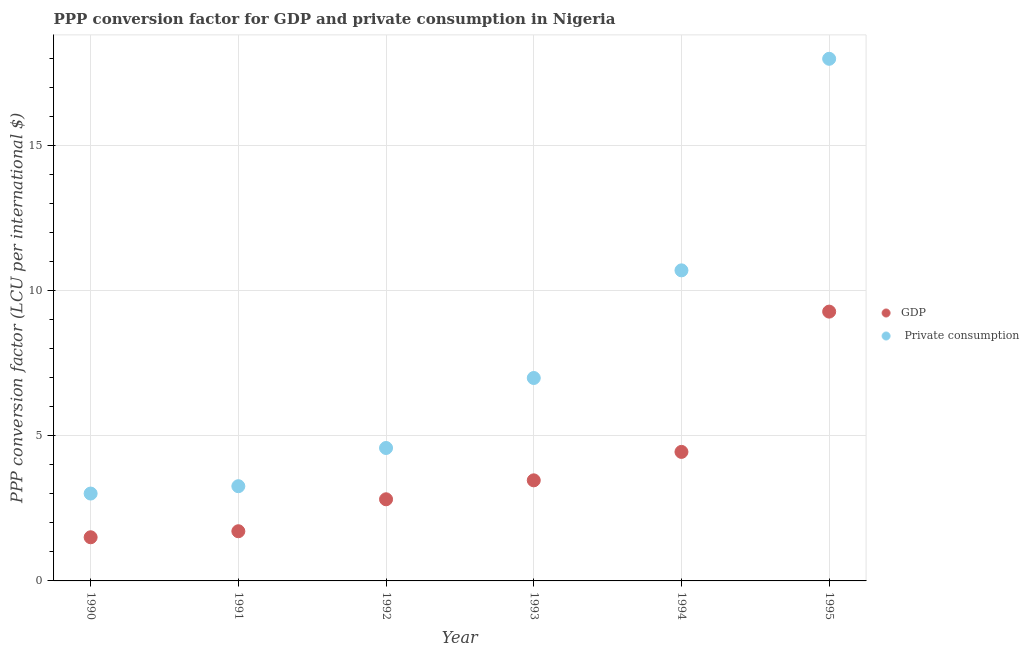How many different coloured dotlines are there?
Offer a very short reply. 2. Is the number of dotlines equal to the number of legend labels?
Make the answer very short. Yes. What is the ppp conversion factor for gdp in 1995?
Your answer should be very brief. 9.27. Across all years, what is the maximum ppp conversion factor for private consumption?
Your response must be concise. 17.98. Across all years, what is the minimum ppp conversion factor for private consumption?
Offer a very short reply. 3.01. In which year was the ppp conversion factor for private consumption maximum?
Your answer should be compact. 1995. What is the total ppp conversion factor for private consumption in the graph?
Ensure brevity in your answer.  46.52. What is the difference between the ppp conversion factor for gdp in 1990 and that in 1994?
Your answer should be compact. -2.94. What is the difference between the ppp conversion factor for gdp in 1990 and the ppp conversion factor for private consumption in 1991?
Your answer should be compact. -1.76. What is the average ppp conversion factor for private consumption per year?
Give a very brief answer. 7.75. In the year 1994, what is the difference between the ppp conversion factor for gdp and ppp conversion factor for private consumption?
Your answer should be very brief. -6.25. What is the ratio of the ppp conversion factor for gdp in 1994 to that in 1995?
Offer a terse response. 0.48. Is the ppp conversion factor for private consumption in 1991 less than that in 1992?
Give a very brief answer. Yes. What is the difference between the highest and the second highest ppp conversion factor for gdp?
Give a very brief answer. 4.83. What is the difference between the highest and the lowest ppp conversion factor for private consumption?
Your response must be concise. 14.97. In how many years, is the ppp conversion factor for private consumption greater than the average ppp conversion factor for private consumption taken over all years?
Make the answer very short. 2. Is the ppp conversion factor for private consumption strictly greater than the ppp conversion factor for gdp over the years?
Provide a short and direct response. Yes. Is the ppp conversion factor for private consumption strictly less than the ppp conversion factor for gdp over the years?
Provide a succinct answer. No. Does the graph contain any zero values?
Provide a short and direct response. No. Does the graph contain grids?
Provide a short and direct response. Yes. Where does the legend appear in the graph?
Your response must be concise. Center right. How many legend labels are there?
Your answer should be very brief. 2. How are the legend labels stacked?
Your answer should be compact. Vertical. What is the title of the graph?
Keep it short and to the point. PPP conversion factor for GDP and private consumption in Nigeria. What is the label or title of the Y-axis?
Make the answer very short. PPP conversion factor (LCU per international $). What is the PPP conversion factor (LCU per international $) of GDP in 1990?
Your answer should be compact. 1.5. What is the PPP conversion factor (LCU per international $) in  Private consumption in 1990?
Offer a very short reply. 3.01. What is the PPP conversion factor (LCU per international $) of GDP in 1991?
Give a very brief answer. 1.71. What is the PPP conversion factor (LCU per international $) of  Private consumption in 1991?
Your answer should be compact. 3.26. What is the PPP conversion factor (LCU per international $) in GDP in 1992?
Your answer should be very brief. 2.81. What is the PPP conversion factor (LCU per international $) of  Private consumption in 1992?
Offer a terse response. 4.58. What is the PPP conversion factor (LCU per international $) in GDP in 1993?
Your response must be concise. 3.46. What is the PPP conversion factor (LCU per international $) in  Private consumption in 1993?
Offer a terse response. 6.99. What is the PPP conversion factor (LCU per international $) in GDP in 1994?
Make the answer very short. 4.44. What is the PPP conversion factor (LCU per international $) in  Private consumption in 1994?
Provide a succinct answer. 10.7. What is the PPP conversion factor (LCU per international $) of GDP in 1995?
Ensure brevity in your answer.  9.27. What is the PPP conversion factor (LCU per international $) in  Private consumption in 1995?
Keep it short and to the point. 17.98. Across all years, what is the maximum PPP conversion factor (LCU per international $) of GDP?
Your answer should be very brief. 9.27. Across all years, what is the maximum PPP conversion factor (LCU per international $) of  Private consumption?
Give a very brief answer. 17.98. Across all years, what is the minimum PPP conversion factor (LCU per international $) of GDP?
Ensure brevity in your answer.  1.5. Across all years, what is the minimum PPP conversion factor (LCU per international $) in  Private consumption?
Offer a terse response. 3.01. What is the total PPP conversion factor (LCU per international $) in GDP in the graph?
Your response must be concise. 23.21. What is the total PPP conversion factor (LCU per international $) of  Private consumption in the graph?
Your response must be concise. 46.52. What is the difference between the PPP conversion factor (LCU per international $) of GDP in 1990 and that in 1991?
Your response must be concise. -0.21. What is the difference between the PPP conversion factor (LCU per international $) of  Private consumption in 1990 and that in 1991?
Your answer should be very brief. -0.25. What is the difference between the PPP conversion factor (LCU per international $) of GDP in 1990 and that in 1992?
Offer a terse response. -1.31. What is the difference between the PPP conversion factor (LCU per international $) in  Private consumption in 1990 and that in 1992?
Provide a short and direct response. -1.57. What is the difference between the PPP conversion factor (LCU per international $) of GDP in 1990 and that in 1993?
Keep it short and to the point. -1.96. What is the difference between the PPP conversion factor (LCU per international $) in  Private consumption in 1990 and that in 1993?
Offer a terse response. -3.98. What is the difference between the PPP conversion factor (LCU per international $) of GDP in 1990 and that in 1994?
Provide a short and direct response. -2.94. What is the difference between the PPP conversion factor (LCU per international $) in  Private consumption in 1990 and that in 1994?
Your answer should be compact. -7.69. What is the difference between the PPP conversion factor (LCU per international $) of GDP in 1990 and that in 1995?
Ensure brevity in your answer.  -7.77. What is the difference between the PPP conversion factor (LCU per international $) of  Private consumption in 1990 and that in 1995?
Give a very brief answer. -14.97. What is the difference between the PPP conversion factor (LCU per international $) in GDP in 1991 and that in 1992?
Your response must be concise. -1.1. What is the difference between the PPP conversion factor (LCU per international $) of  Private consumption in 1991 and that in 1992?
Offer a very short reply. -1.32. What is the difference between the PPP conversion factor (LCU per international $) of GDP in 1991 and that in 1993?
Your response must be concise. -1.75. What is the difference between the PPP conversion factor (LCU per international $) of  Private consumption in 1991 and that in 1993?
Offer a terse response. -3.73. What is the difference between the PPP conversion factor (LCU per international $) of GDP in 1991 and that in 1994?
Your answer should be very brief. -2.73. What is the difference between the PPP conversion factor (LCU per international $) of  Private consumption in 1991 and that in 1994?
Your answer should be compact. -7.43. What is the difference between the PPP conversion factor (LCU per international $) of GDP in 1991 and that in 1995?
Your answer should be compact. -7.56. What is the difference between the PPP conversion factor (LCU per international $) in  Private consumption in 1991 and that in 1995?
Provide a succinct answer. -14.72. What is the difference between the PPP conversion factor (LCU per international $) of GDP in 1992 and that in 1993?
Keep it short and to the point. -0.65. What is the difference between the PPP conversion factor (LCU per international $) in  Private consumption in 1992 and that in 1993?
Keep it short and to the point. -2.41. What is the difference between the PPP conversion factor (LCU per international $) of GDP in 1992 and that in 1994?
Offer a terse response. -1.63. What is the difference between the PPP conversion factor (LCU per international $) in  Private consumption in 1992 and that in 1994?
Give a very brief answer. -6.12. What is the difference between the PPP conversion factor (LCU per international $) in GDP in 1992 and that in 1995?
Offer a very short reply. -6.46. What is the difference between the PPP conversion factor (LCU per international $) of  Private consumption in 1992 and that in 1995?
Ensure brevity in your answer.  -13.4. What is the difference between the PPP conversion factor (LCU per international $) of GDP in 1993 and that in 1994?
Keep it short and to the point. -0.98. What is the difference between the PPP conversion factor (LCU per international $) of  Private consumption in 1993 and that in 1994?
Offer a very short reply. -3.71. What is the difference between the PPP conversion factor (LCU per international $) of GDP in 1993 and that in 1995?
Make the answer very short. -5.81. What is the difference between the PPP conversion factor (LCU per international $) in  Private consumption in 1993 and that in 1995?
Keep it short and to the point. -10.99. What is the difference between the PPP conversion factor (LCU per international $) in GDP in 1994 and that in 1995?
Give a very brief answer. -4.83. What is the difference between the PPP conversion factor (LCU per international $) of  Private consumption in 1994 and that in 1995?
Keep it short and to the point. -7.29. What is the difference between the PPP conversion factor (LCU per international $) of GDP in 1990 and the PPP conversion factor (LCU per international $) of  Private consumption in 1991?
Offer a terse response. -1.76. What is the difference between the PPP conversion factor (LCU per international $) in GDP in 1990 and the PPP conversion factor (LCU per international $) in  Private consumption in 1992?
Your response must be concise. -3.07. What is the difference between the PPP conversion factor (LCU per international $) in GDP in 1990 and the PPP conversion factor (LCU per international $) in  Private consumption in 1993?
Your response must be concise. -5.49. What is the difference between the PPP conversion factor (LCU per international $) in GDP in 1990 and the PPP conversion factor (LCU per international $) in  Private consumption in 1994?
Ensure brevity in your answer.  -9.19. What is the difference between the PPP conversion factor (LCU per international $) of GDP in 1990 and the PPP conversion factor (LCU per international $) of  Private consumption in 1995?
Ensure brevity in your answer.  -16.48. What is the difference between the PPP conversion factor (LCU per international $) of GDP in 1991 and the PPP conversion factor (LCU per international $) of  Private consumption in 1992?
Provide a succinct answer. -2.87. What is the difference between the PPP conversion factor (LCU per international $) of GDP in 1991 and the PPP conversion factor (LCU per international $) of  Private consumption in 1993?
Your answer should be compact. -5.28. What is the difference between the PPP conversion factor (LCU per international $) in GDP in 1991 and the PPP conversion factor (LCU per international $) in  Private consumption in 1994?
Keep it short and to the point. -8.98. What is the difference between the PPP conversion factor (LCU per international $) in GDP in 1991 and the PPP conversion factor (LCU per international $) in  Private consumption in 1995?
Offer a very short reply. -16.27. What is the difference between the PPP conversion factor (LCU per international $) in GDP in 1992 and the PPP conversion factor (LCU per international $) in  Private consumption in 1993?
Make the answer very short. -4.18. What is the difference between the PPP conversion factor (LCU per international $) in GDP in 1992 and the PPP conversion factor (LCU per international $) in  Private consumption in 1994?
Provide a succinct answer. -7.88. What is the difference between the PPP conversion factor (LCU per international $) in GDP in 1992 and the PPP conversion factor (LCU per international $) in  Private consumption in 1995?
Provide a succinct answer. -15.17. What is the difference between the PPP conversion factor (LCU per international $) in GDP in 1993 and the PPP conversion factor (LCU per international $) in  Private consumption in 1994?
Offer a very short reply. -7.23. What is the difference between the PPP conversion factor (LCU per international $) of GDP in 1993 and the PPP conversion factor (LCU per international $) of  Private consumption in 1995?
Ensure brevity in your answer.  -14.52. What is the difference between the PPP conversion factor (LCU per international $) of GDP in 1994 and the PPP conversion factor (LCU per international $) of  Private consumption in 1995?
Keep it short and to the point. -13.54. What is the average PPP conversion factor (LCU per international $) of GDP per year?
Your answer should be compact. 3.87. What is the average PPP conversion factor (LCU per international $) in  Private consumption per year?
Your response must be concise. 7.75. In the year 1990, what is the difference between the PPP conversion factor (LCU per international $) of GDP and PPP conversion factor (LCU per international $) of  Private consumption?
Your answer should be compact. -1.51. In the year 1991, what is the difference between the PPP conversion factor (LCU per international $) in GDP and PPP conversion factor (LCU per international $) in  Private consumption?
Give a very brief answer. -1.55. In the year 1992, what is the difference between the PPP conversion factor (LCU per international $) in GDP and PPP conversion factor (LCU per international $) in  Private consumption?
Your answer should be very brief. -1.77. In the year 1993, what is the difference between the PPP conversion factor (LCU per international $) of GDP and PPP conversion factor (LCU per international $) of  Private consumption?
Make the answer very short. -3.52. In the year 1994, what is the difference between the PPP conversion factor (LCU per international $) in GDP and PPP conversion factor (LCU per international $) in  Private consumption?
Ensure brevity in your answer.  -6.25. In the year 1995, what is the difference between the PPP conversion factor (LCU per international $) in GDP and PPP conversion factor (LCU per international $) in  Private consumption?
Keep it short and to the point. -8.71. What is the ratio of the PPP conversion factor (LCU per international $) in GDP in 1990 to that in 1991?
Offer a very short reply. 0.88. What is the ratio of the PPP conversion factor (LCU per international $) in  Private consumption in 1990 to that in 1991?
Your answer should be very brief. 0.92. What is the ratio of the PPP conversion factor (LCU per international $) of GDP in 1990 to that in 1992?
Your answer should be compact. 0.53. What is the ratio of the PPP conversion factor (LCU per international $) in  Private consumption in 1990 to that in 1992?
Your response must be concise. 0.66. What is the ratio of the PPP conversion factor (LCU per international $) in GDP in 1990 to that in 1993?
Offer a terse response. 0.43. What is the ratio of the PPP conversion factor (LCU per international $) of  Private consumption in 1990 to that in 1993?
Provide a succinct answer. 0.43. What is the ratio of the PPP conversion factor (LCU per international $) in GDP in 1990 to that in 1994?
Offer a very short reply. 0.34. What is the ratio of the PPP conversion factor (LCU per international $) in  Private consumption in 1990 to that in 1994?
Offer a terse response. 0.28. What is the ratio of the PPP conversion factor (LCU per international $) in GDP in 1990 to that in 1995?
Keep it short and to the point. 0.16. What is the ratio of the PPP conversion factor (LCU per international $) in  Private consumption in 1990 to that in 1995?
Provide a short and direct response. 0.17. What is the ratio of the PPP conversion factor (LCU per international $) in GDP in 1991 to that in 1992?
Offer a very short reply. 0.61. What is the ratio of the PPP conversion factor (LCU per international $) of  Private consumption in 1991 to that in 1992?
Give a very brief answer. 0.71. What is the ratio of the PPP conversion factor (LCU per international $) of GDP in 1991 to that in 1993?
Your response must be concise. 0.49. What is the ratio of the PPP conversion factor (LCU per international $) of  Private consumption in 1991 to that in 1993?
Your answer should be compact. 0.47. What is the ratio of the PPP conversion factor (LCU per international $) in GDP in 1991 to that in 1994?
Make the answer very short. 0.39. What is the ratio of the PPP conversion factor (LCU per international $) in  Private consumption in 1991 to that in 1994?
Provide a short and direct response. 0.3. What is the ratio of the PPP conversion factor (LCU per international $) of GDP in 1991 to that in 1995?
Keep it short and to the point. 0.18. What is the ratio of the PPP conversion factor (LCU per international $) of  Private consumption in 1991 to that in 1995?
Provide a short and direct response. 0.18. What is the ratio of the PPP conversion factor (LCU per international $) in GDP in 1992 to that in 1993?
Make the answer very short. 0.81. What is the ratio of the PPP conversion factor (LCU per international $) of  Private consumption in 1992 to that in 1993?
Make the answer very short. 0.66. What is the ratio of the PPP conversion factor (LCU per international $) in GDP in 1992 to that in 1994?
Your answer should be very brief. 0.63. What is the ratio of the PPP conversion factor (LCU per international $) in  Private consumption in 1992 to that in 1994?
Offer a terse response. 0.43. What is the ratio of the PPP conversion factor (LCU per international $) of GDP in 1992 to that in 1995?
Provide a succinct answer. 0.3. What is the ratio of the PPP conversion factor (LCU per international $) in  Private consumption in 1992 to that in 1995?
Offer a terse response. 0.25. What is the ratio of the PPP conversion factor (LCU per international $) in GDP in 1993 to that in 1994?
Give a very brief answer. 0.78. What is the ratio of the PPP conversion factor (LCU per international $) in  Private consumption in 1993 to that in 1994?
Offer a very short reply. 0.65. What is the ratio of the PPP conversion factor (LCU per international $) of GDP in 1993 to that in 1995?
Keep it short and to the point. 0.37. What is the ratio of the PPP conversion factor (LCU per international $) in  Private consumption in 1993 to that in 1995?
Ensure brevity in your answer.  0.39. What is the ratio of the PPP conversion factor (LCU per international $) in GDP in 1994 to that in 1995?
Provide a succinct answer. 0.48. What is the ratio of the PPP conversion factor (LCU per international $) in  Private consumption in 1994 to that in 1995?
Give a very brief answer. 0.59. What is the difference between the highest and the second highest PPP conversion factor (LCU per international $) in GDP?
Make the answer very short. 4.83. What is the difference between the highest and the second highest PPP conversion factor (LCU per international $) of  Private consumption?
Give a very brief answer. 7.29. What is the difference between the highest and the lowest PPP conversion factor (LCU per international $) in GDP?
Provide a short and direct response. 7.77. What is the difference between the highest and the lowest PPP conversion factor (LCU per international $) in  Private consumption?
Ensure brevity in your answer.  14.97. 